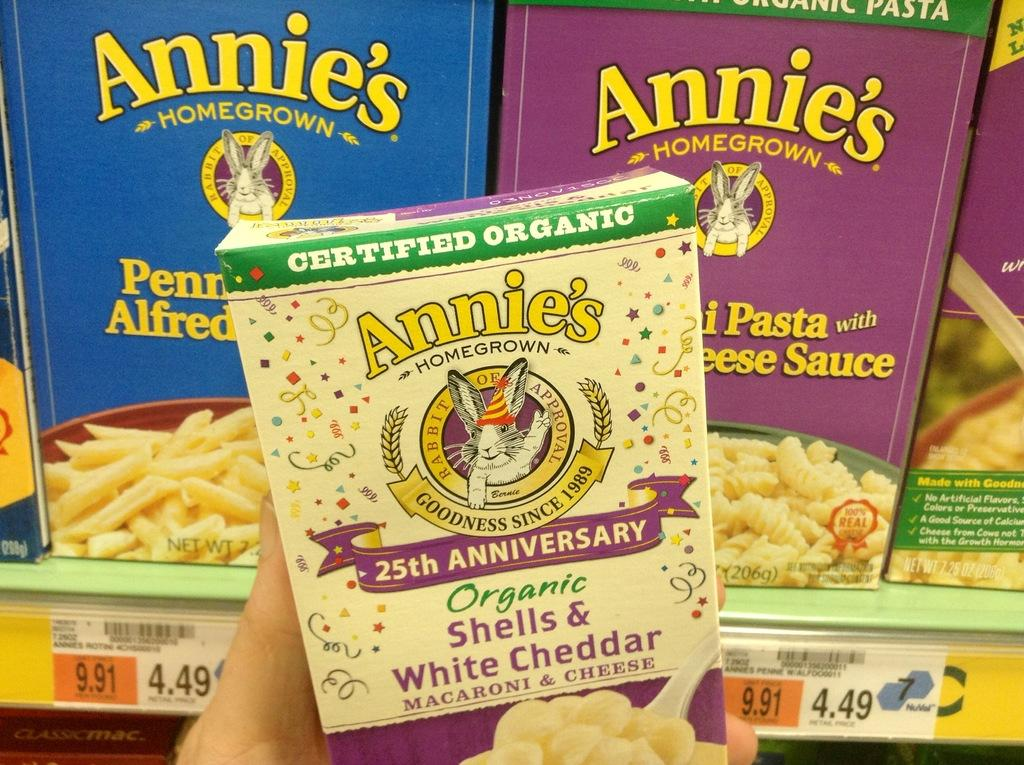What type of objects are present in the image? There are cardboard boxes in the image. Can you describe the appearance of the cardboard boxes? The cardboard boxes are in multiple colors. Is there any text or markings on the cardboard boxes? Yes, there is writing on the cardboard boxes. What type of vegetable is being used as a notebook in the image? There is no vegetable being used as a notebook in the image; the image features cardboard boxes with writing on them. 